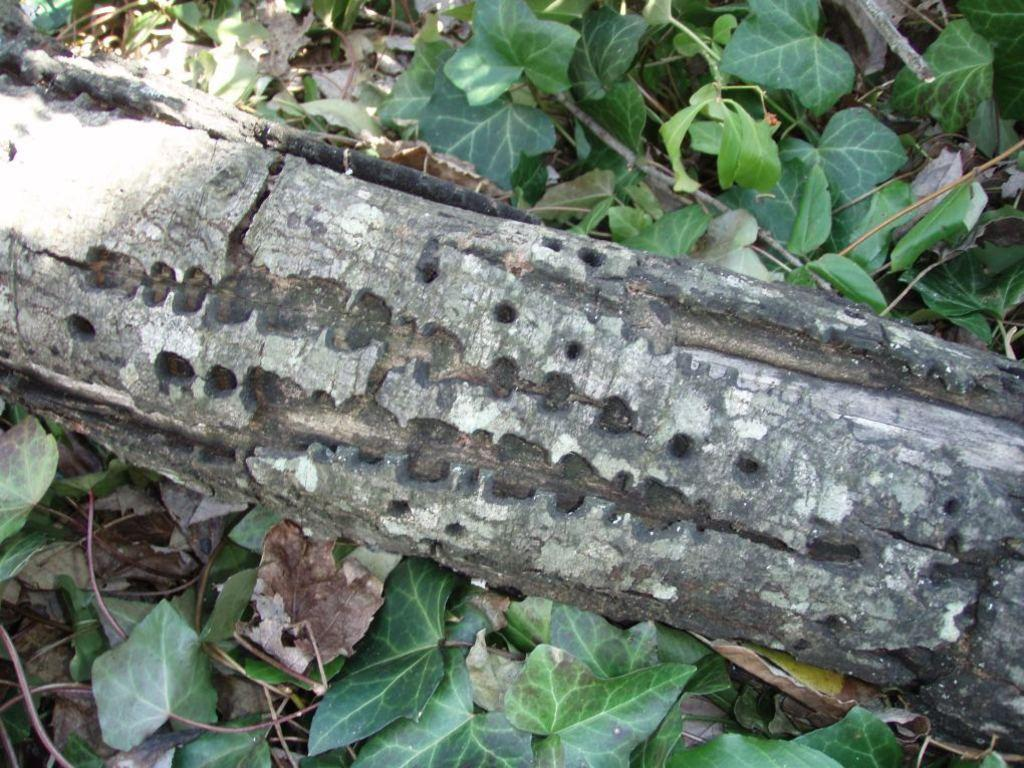What is the main object in the center of the image? There is a log in the center of the image. What type of vegetation can be seen in the image? There are leaves in the image. Where is the pet located in the image? There is no pet present in the image. What type of paper can be seen in the image? There is no paper present in the image. 